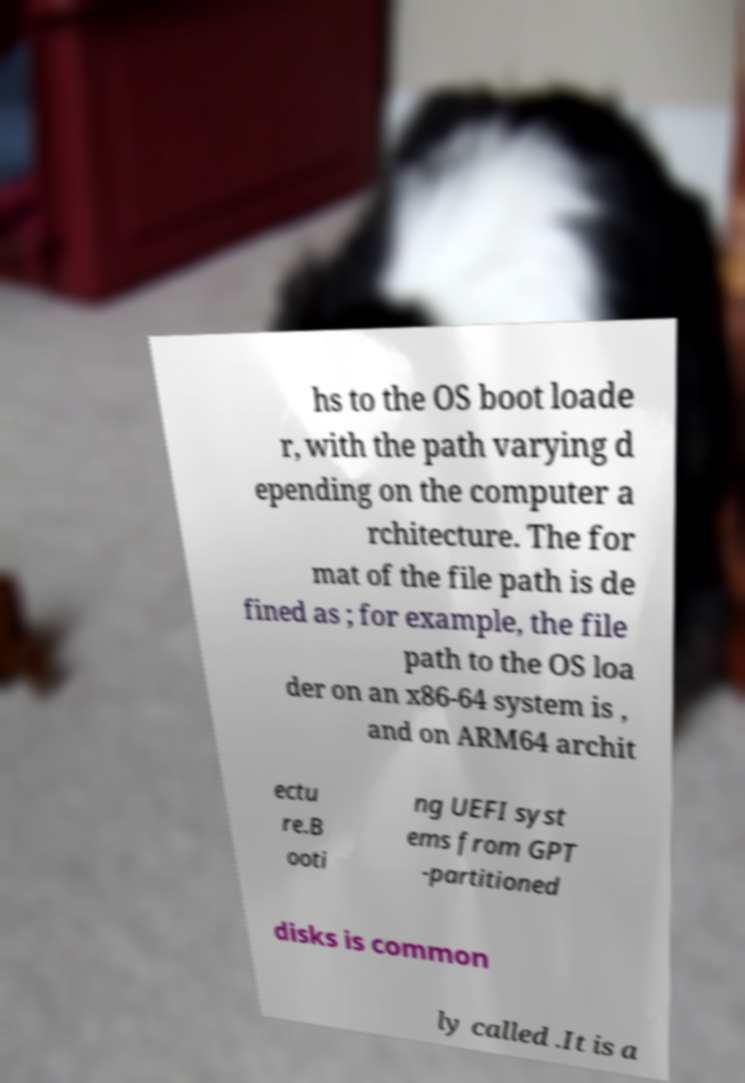There's text embedded in this image that I need extracted. Can you transcribe it verbatim? hs to the OS boot loade r, with the path varying d epending on the computer a rchitecture. The for mat of the file path is de fined as ; for example, the file path to the OS loa der on an x86-64 system is , and on ARM64 archit ectu re.B ooti ng UEFI syst ems from GPT -partitioned disks is common ly called .It is a 